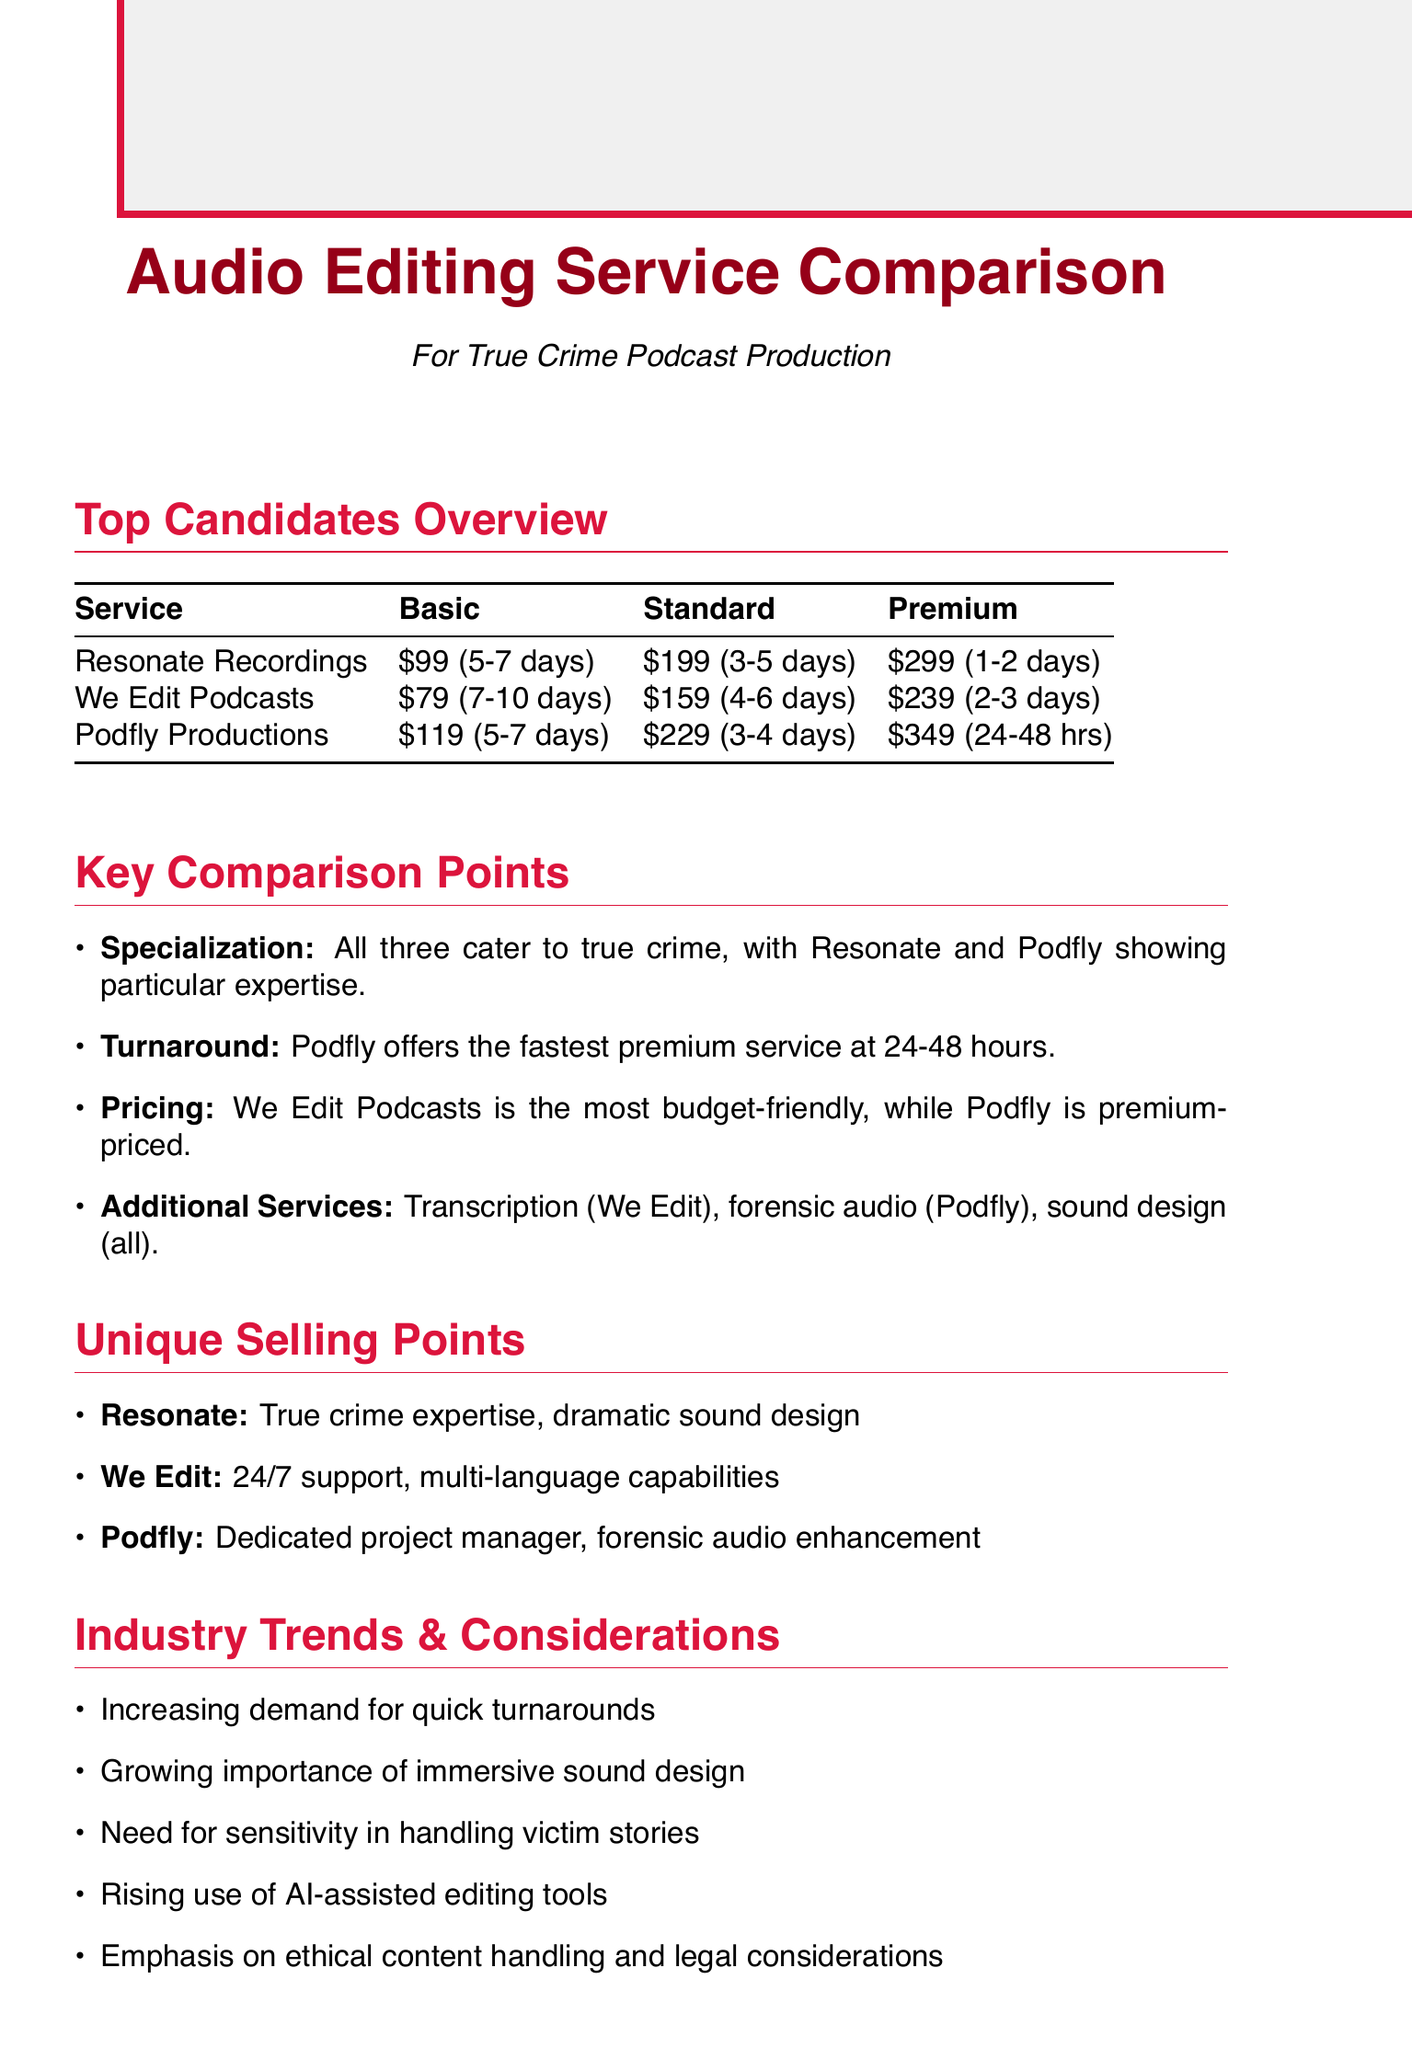What is the basic pricing for We Edit Podcasts? The basic pricing for We Edit Podcasts is stated in the pricing section of the document.
Answer: $79 per episode What is the turnaround time for the premium service of Podfly Productions? The turnaround time for Podfly's premium service is included in the turnaround time details of the document.
Answer: 24-48 hours Which service offers transcription services? The document lists additional features offered by each service, including transcription services.
Answer: We Edit Podcasts What is a unique feature of Resonate Recordings? The document highlights unique selling points for each service, including Resonate's specialization.
Answer: True crime expertise, dramatic sound design What is the total price of the premium service for Podfly Productions? The document provides the premium pricing for Podfly Productions.
Answer: $349 per episode Which service has the fastest turnaround time across all service levels? The turnaround times are compared for each service, indicating which one is the fastest overall.
Answer: Podfly Productions How many business days does the standard service of We Edit Podcasts take? The document provides specific turnaround times for each service level for We Edit Podcasts.
Answer: 4-6 business days What common theme is emphasized in the industry trends section? The document includes key points about industry trends that affect true crime podcasting.
Answer: Quick turnaround times 